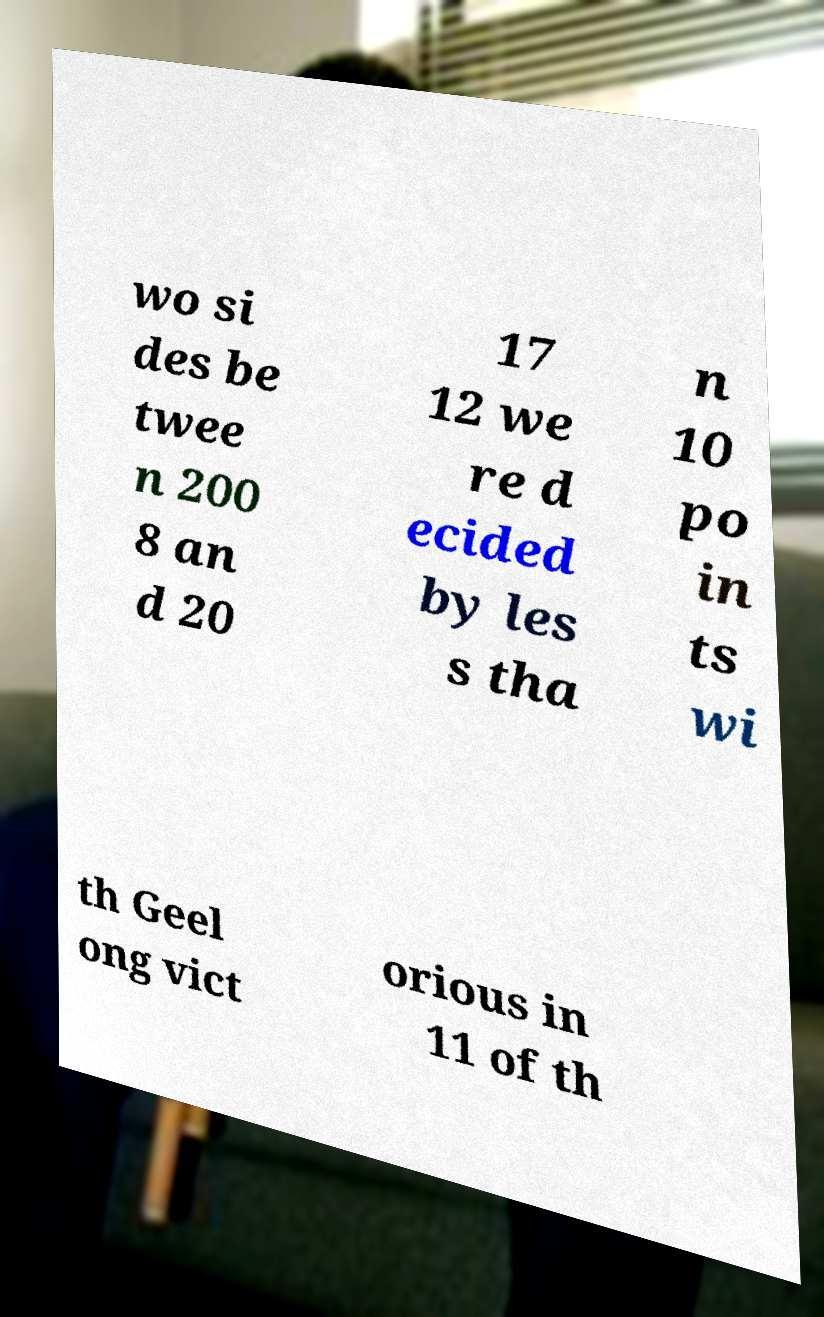I need the written content from this picture converted into text. Can you do that? wo si des be twee n 200 8 an d 20 17 12 we re d ecided by les s tha n 10 po in ts wi th Geel ong vict orious in 11 of th 